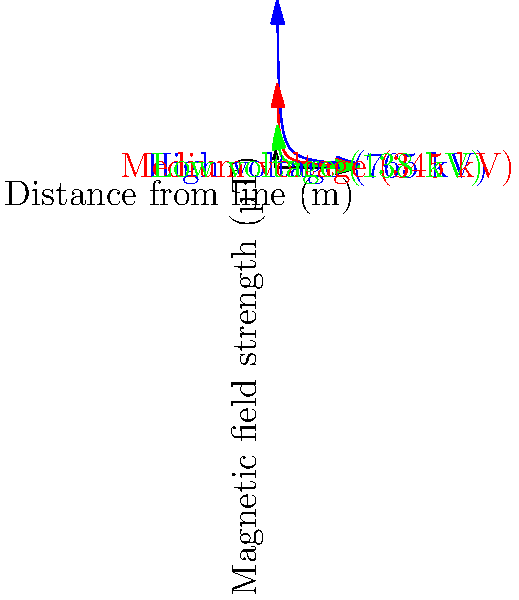Based on the graph showing magnetic field strength vs. distance for different power transmission lines, which type of line produces the strongest electromagnetic field at a distance of 10 meters, and approximately how strong is this field in microteslas (µT)? To solve this problem, we need to follow these steps:

1. Identify the three types of power transmission lines on the graph:
   - Blue line: High voltage (765 kV)
   - Red line: Medium voltage (345 kV)
   - Green line: Low voltage (138 kV)

2. Locate the point on the x-axis corresponding to 10 meters.

3. For each line, find the y-value (magnetic field strength) at x = 10 meters:
   - High voltage (blue): Approximately 10 µT
   - Medium voltage (red): Approximately 5 µT
   - Low voltage (green): Approximately 2.5 µT

4. Compare the three values to determine which is highest.

5. The high voltage line (765 kV) produces the strongest electromagnetic field at 10 meters, with a strength of approximately 10 µT.

This result aligns with the expectation that higher voltage lines generally produce stronger electromagnetic fields. The graph also shows that field strength decreases rapidly with distance for all line types, following an inverse relationship.
Answer: High voltage (765 kV) line, approximately 10 µT 